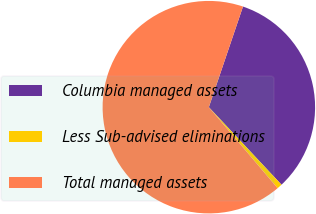<chart> <loc_0><loc_0><loc_500><loc_500><pie_chart><fcel>Columbia managed assets<fcel>Less Sub-advised eliminations<fcel>Total managed assets<nl><fcel>32.81%<fcel>0.78%<fcel>66.41%<nl></chart> 